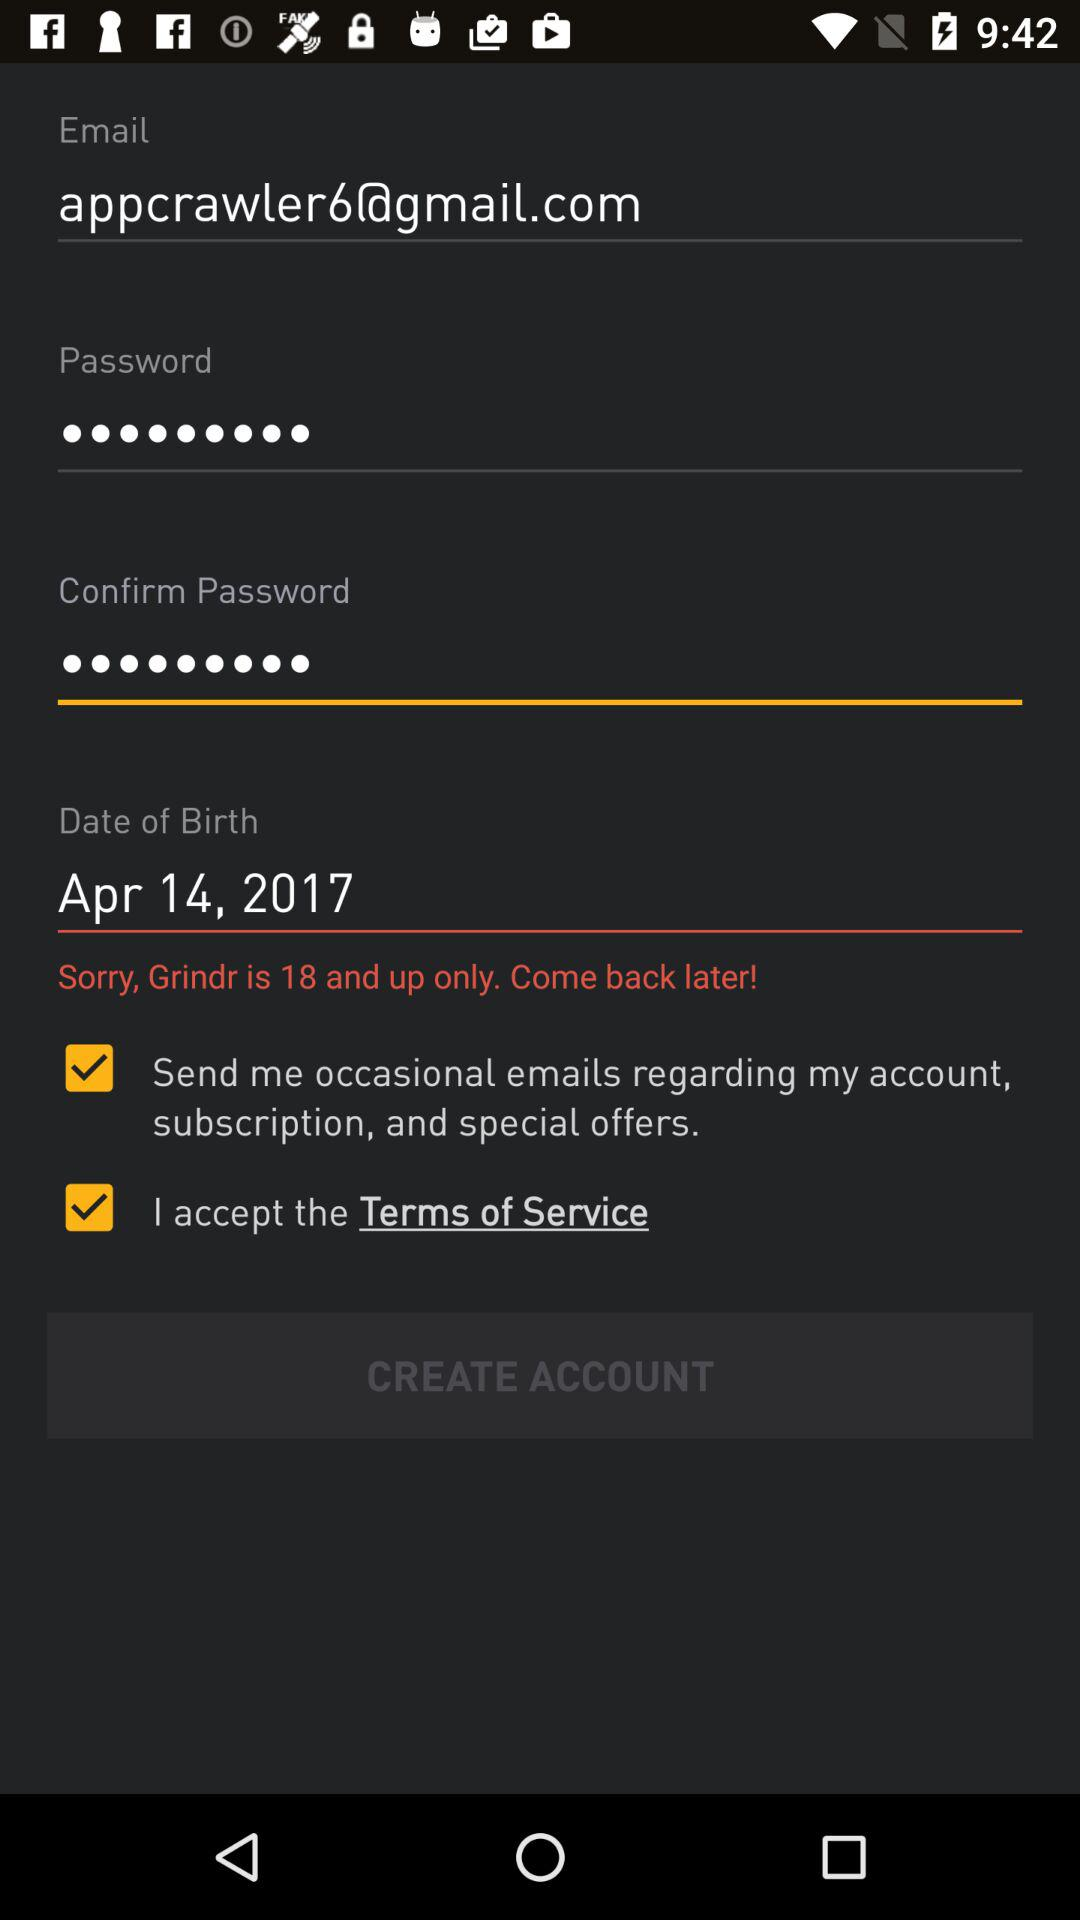What is the email address? The email address is appcrawler6@gmail.com. 